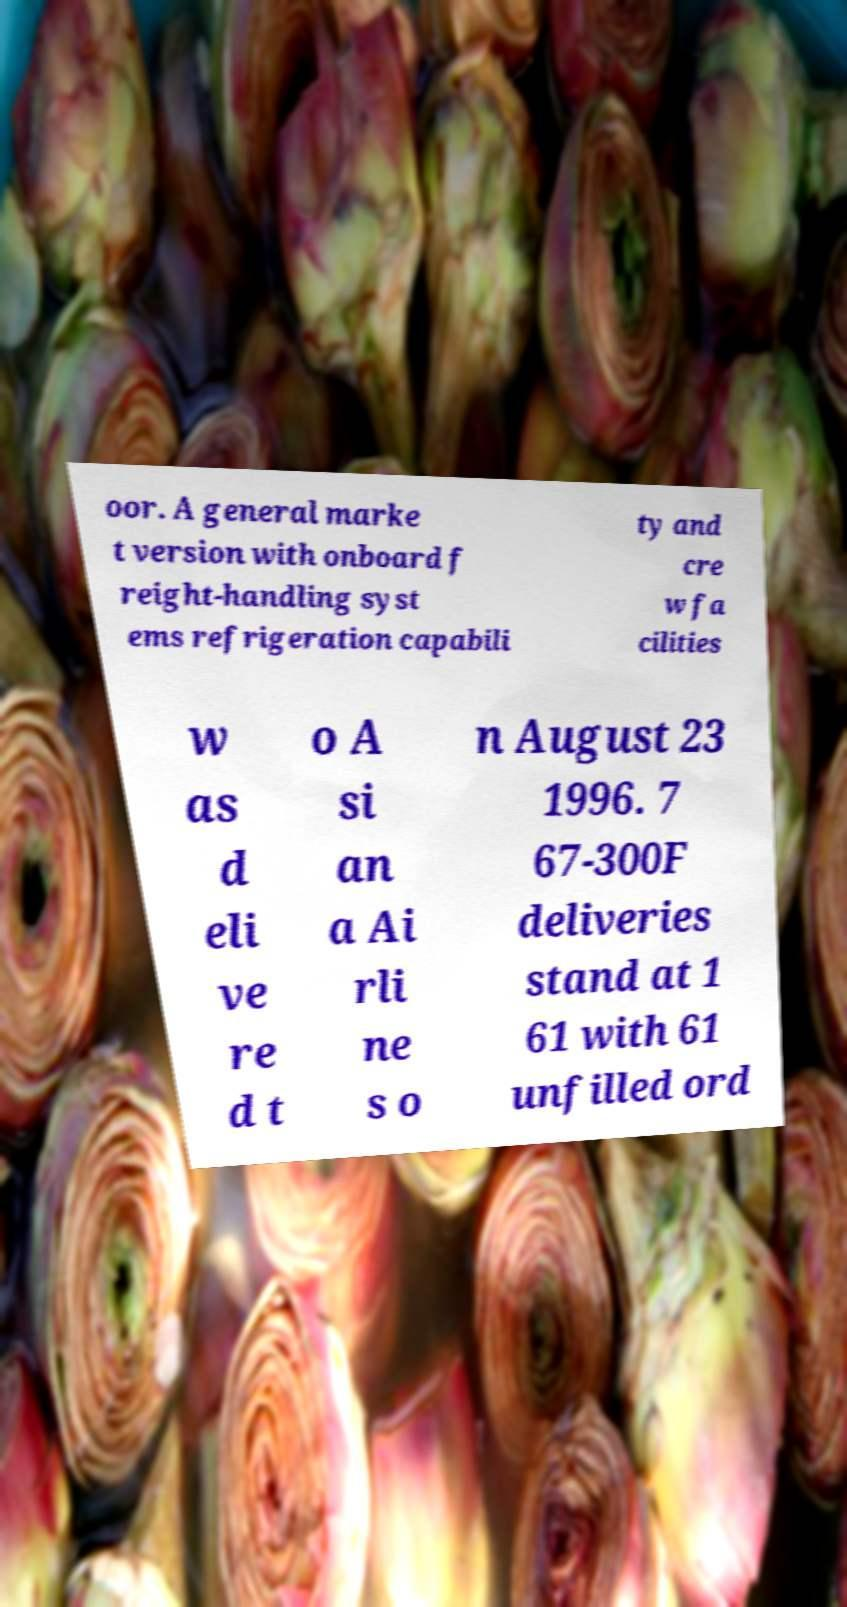What messages or text are displayed in this image? I need them in a readable, typed format. oor. A general marke t version with onboard f reight-handling syst ems refrigeration capabili ty and cre w fa cilities w as d eli ve re d t o A si an a Ai rli ne s o n August 23 1996. 7 67-300F deliveries stand at 1 61 with 61 unfilled ord 